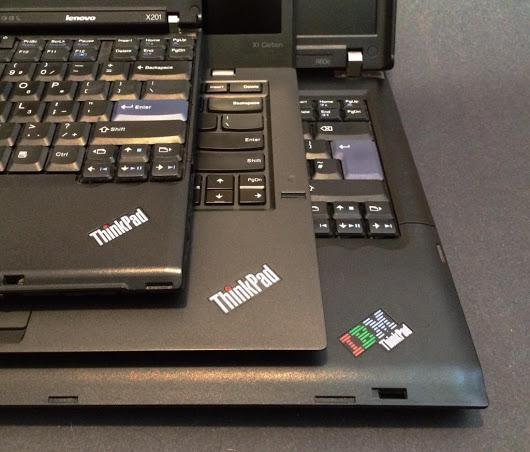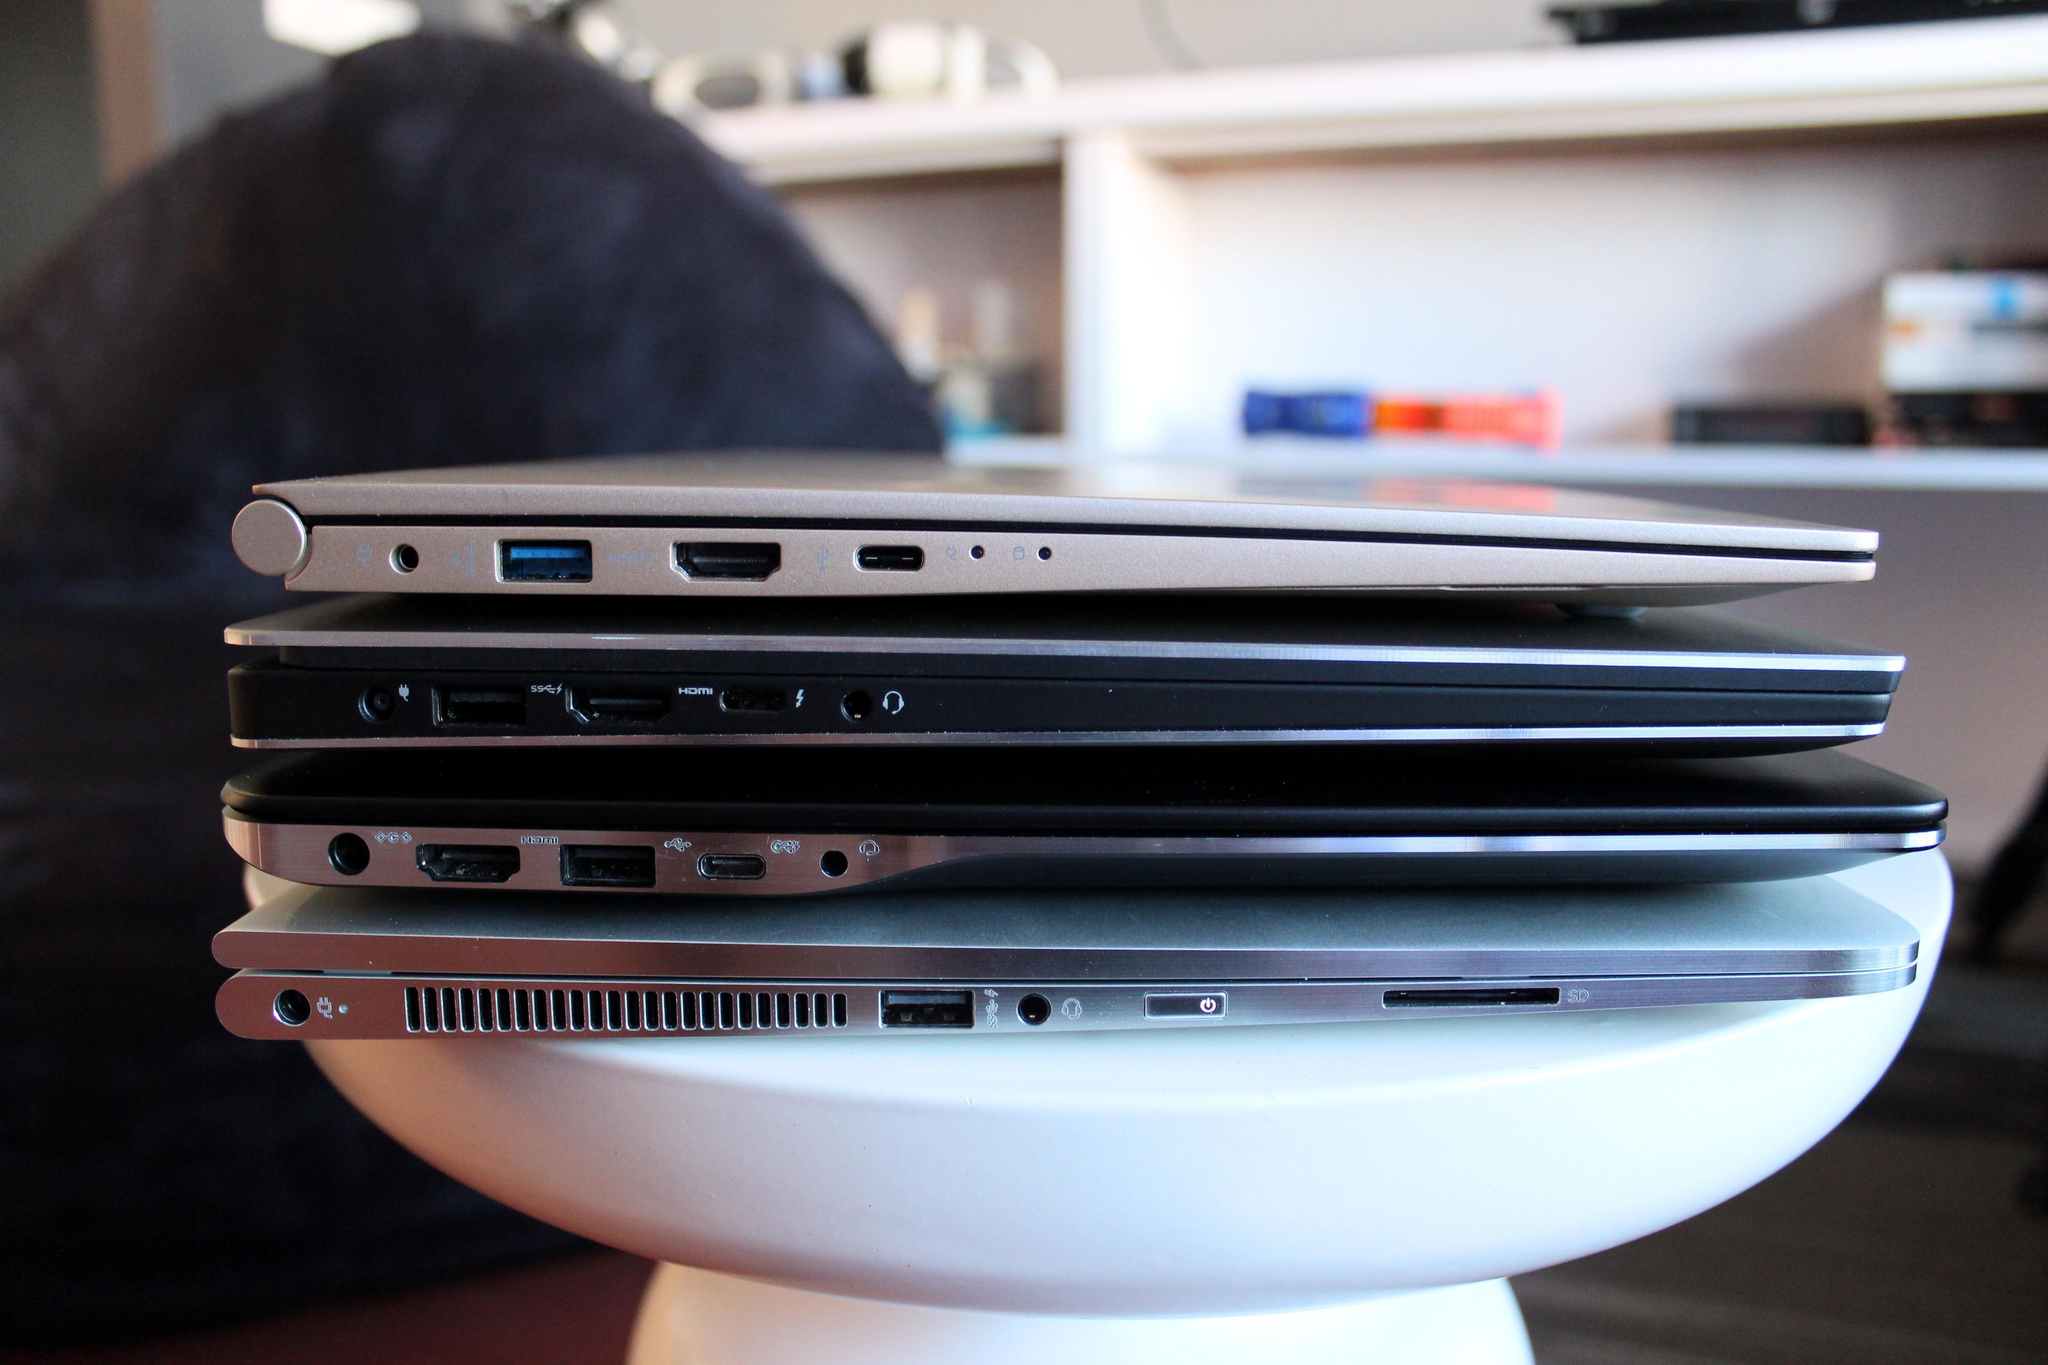The first image is the image on the left, the second image is the image on the right. Evaluate the accuracy of this statement regarding the images: "There is at least one laptop open with the keyboard showing.". Is it true? Answer yes or no. Yes. The first image is the image on the left, the second image is the image on the right. For the images shown, is this caption "In one image at least one laptop is open." true? Answer yes or no. Yes. 